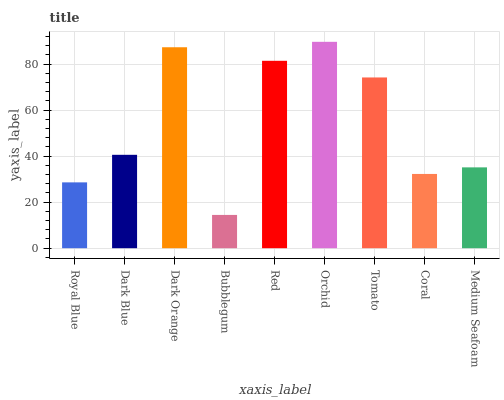Is Dark Blue the minimum?
Answer yes or no. No. Is Dark Blue the maximum?
Answer yes or no. No. Is Dark Blue greater than Royal Blue?
Answer yes or no. Yes. Is Royal Blue less than Dark Blue?
Answer yes or no. Yes. Is Royal Blue greater than Dark Blue?
Answer yes or no. No. Is Dark Blue less than Royal Blue?
Answer yes or no. No. Is Dark Blue the high median?
Answer yes or no. Yes. Is Dark Blue the low median?
Answer yes or no. Yes. Is Royal Blue the high median?
Answer yes or no. No. Is Medium Seafoam the low median?
Answer yes or no. No. 